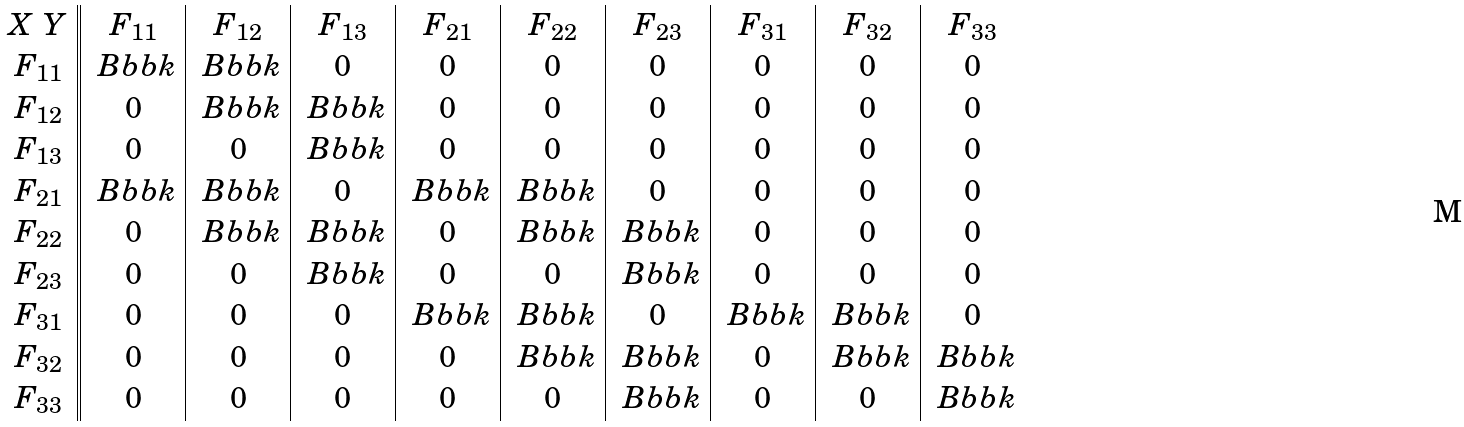Convert formula to latex. <formula><loc_0><loc_0><loc_500><loc_500>\begin{array} { c | | c | c | c | c | c | c | c | c | c } X \ Y & F _ { 1 1 } & F _ { 1 2 } & F _ { 1 3 } & F _ { 2 1 } & F _ { 2 2 } & F _ { 2 3 } & F _ { 3 1 } & F _ { 3 2 } & F _ { 3 3 } \\ F _ { 1 1 } & \ B b b k & \ B b b k & 0 & 0 & 0 & 0 & 0 & 0 & 0 \\ F _ { 1 2 } & 0 & \ B b b k & \ B b b k & 0 & 0 & 0 & 0 & 0 & 0 \\ F _ { 1 3 } & 0 & 0 & \ B b b k & 0 & 0 & 0 & 0 & 0 & 0 \\ F _ { 2 1 } & \ B b b k & \ B b b k & 0 & \ B b b k & \ B b b k & 0 & 0 & 0 & 0 \\ F _ { 2 2 } & 0 & \ B b b k & \ B b b k & 0 & \ B b b k & \ B b b k & 0 & 0 & 0 \\ F _ { 2 3 } & 0 & 0 & \ B b b k & 0 & 0 & \ B b b k & 0 & 0 & 0 \\ F _ { 3 1 } & 0 & 0 & 0 & \ B b b k & \ B b b k & 0 & \ B b b k & \ B b b k & 0 \\ F _ { 3 2 } & 0 & 0 & 0 & 0 & \ B b b k & \ B b b k & 0 & \ B b b k & \ B b b k \\ F _ { 3 3 } & 0 & 0 & 0 & 0 & 0 & \ B b b k & 0 & 0 & \ B b b k \end{array}</formula> 